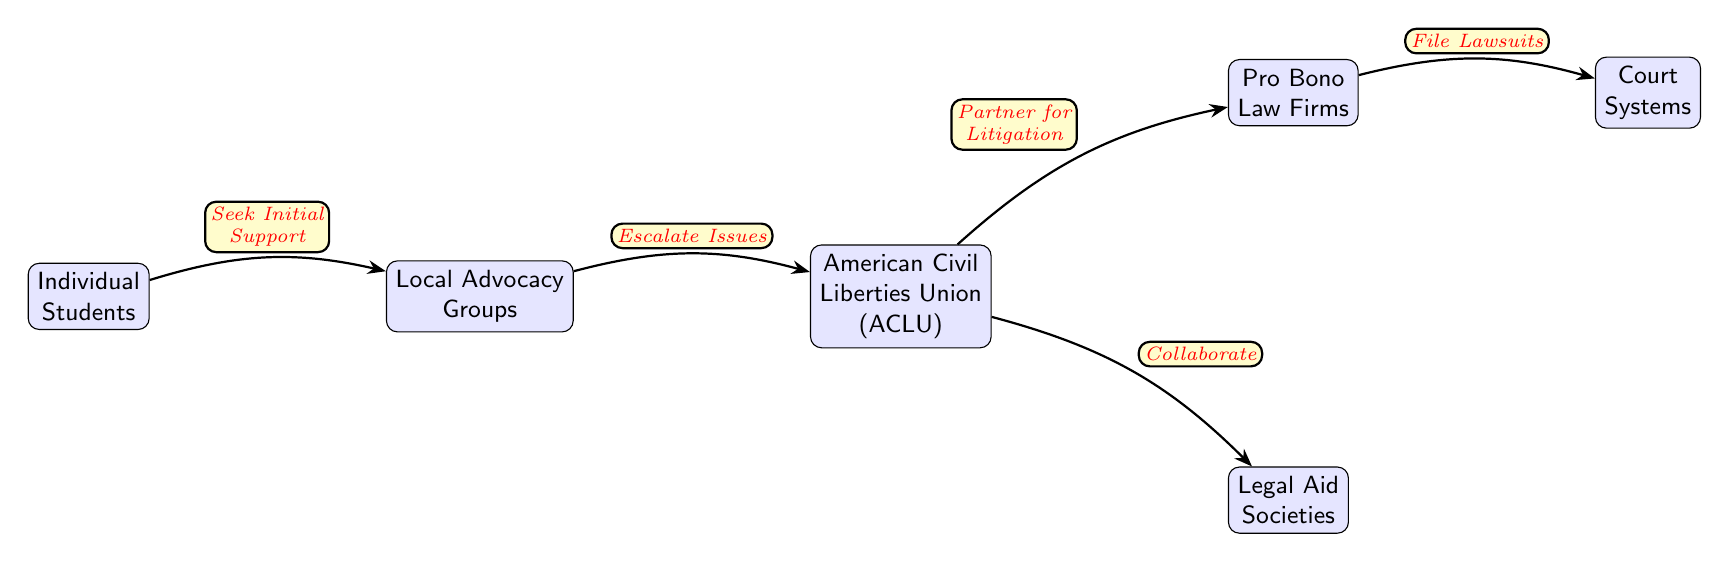What is the first node in the diagram? The first node is "Individual Students," as it is located at the far left side of the diagram.
Answer: Individual Students How many nodes are in the diagram? By counting the nodes shown in the diagram, there are a total of six distinct nodes connected by edges.
Answer: 6 What is the relationship between Local Advocacy Groups and the American Civil Liberties Union? The relationship is "Escalate Issues," indicating that Local Advocacy Groups aim to bring issues to the ACLU's attention for further assistance or action.
Answer: Escalate Issues Which node collaborates with Legal Aid Societies? The node that collaborates with Legal Aid Societies is the "American Civil Liberties Union (ACLU)," as indicated by the direct edge leading from the ACLU to the Legal Aid Societies.
Answer: American Civil Liberties Union (ACLU) What action is taken after Partnering for Litigation? The action taken after "Partner for Litigation" is "File Lawsuits," which is the next step shown in the flow from Pro Bono Law Firms to Court Systems.
Answer: File Lawsuits How many edges are connected to the American Civil Liberties Union? There are two edges connected to the ACLU, one leading to Legal Aid Societies and the other to Pro Bono Law Firms.
Answer: 2 Which nodes represent organizations involved in litigation? The nodes representing organizations involved in litigation are the "American Civil Liberties Union (ACLU)" and "Pro Bono Law Firms," as they both specifically engage in legal actions related to student rights.
Answer: American Civil Liberties Union (ACLU), Pro Bono Law Firms What is the final outcome of the flow in the diagram? The final outcome of the flow illustrated in the diagram is represented by the "Court Systems," which is the endpoint where lawsuits are filed.
Answer: Court Systems What stage comes directly before filing lawsuits? The stage that comes directly before filing lawsuits is "Partner for Litigation," which indicates that partnerships are formed prior to legal action.
Answer: Partner for Litigation 